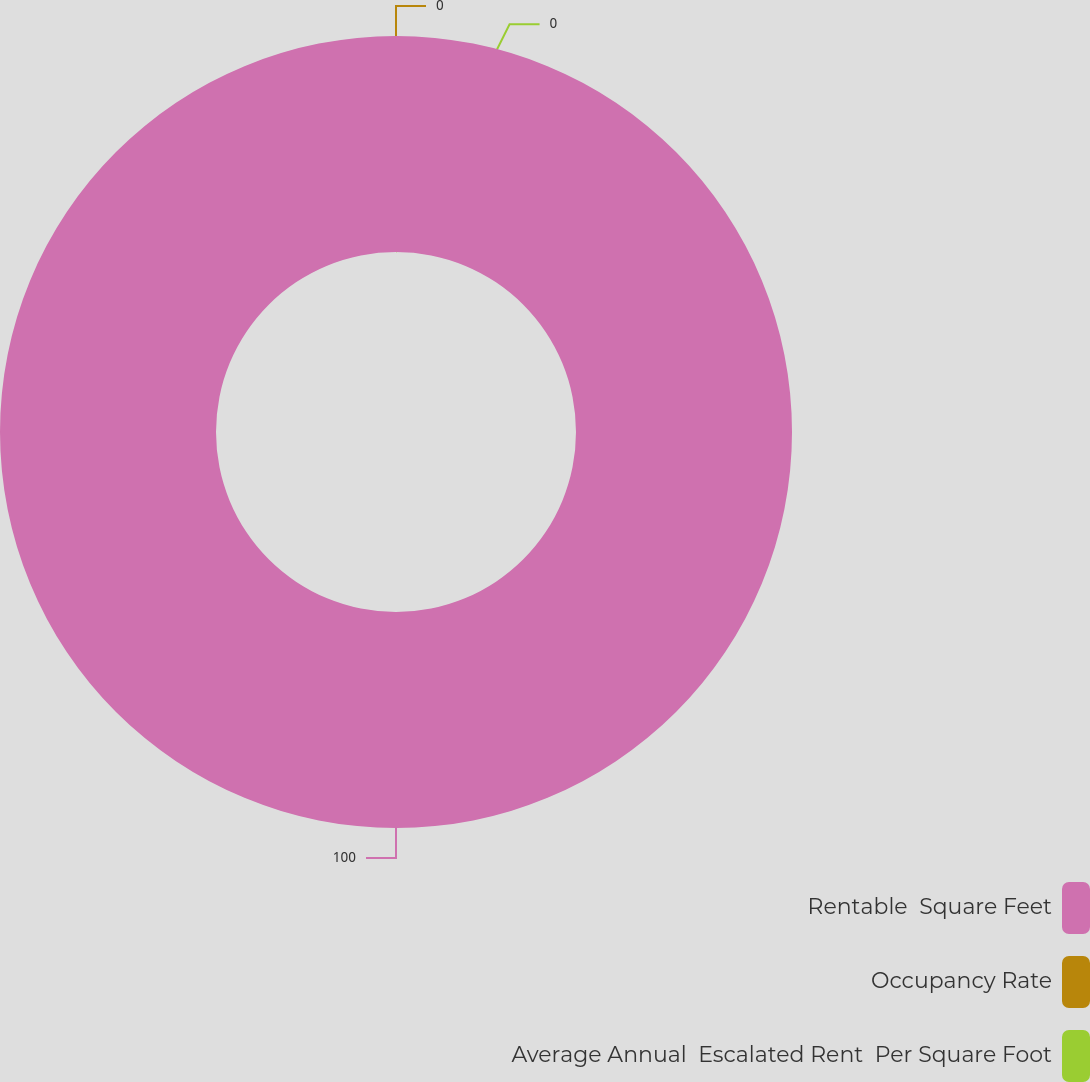<chart> <loc_0><loc_0><loc_500><loc_500><pie_chart><fcel>Rentable  Square Feet<fcel>Occupancy Rate<fcel>Average Annual  Escalated Rent  Per Square Foot<nl><fcel>100.0%<fcel>0.0%<fcel>0.0%<nl></chart> 